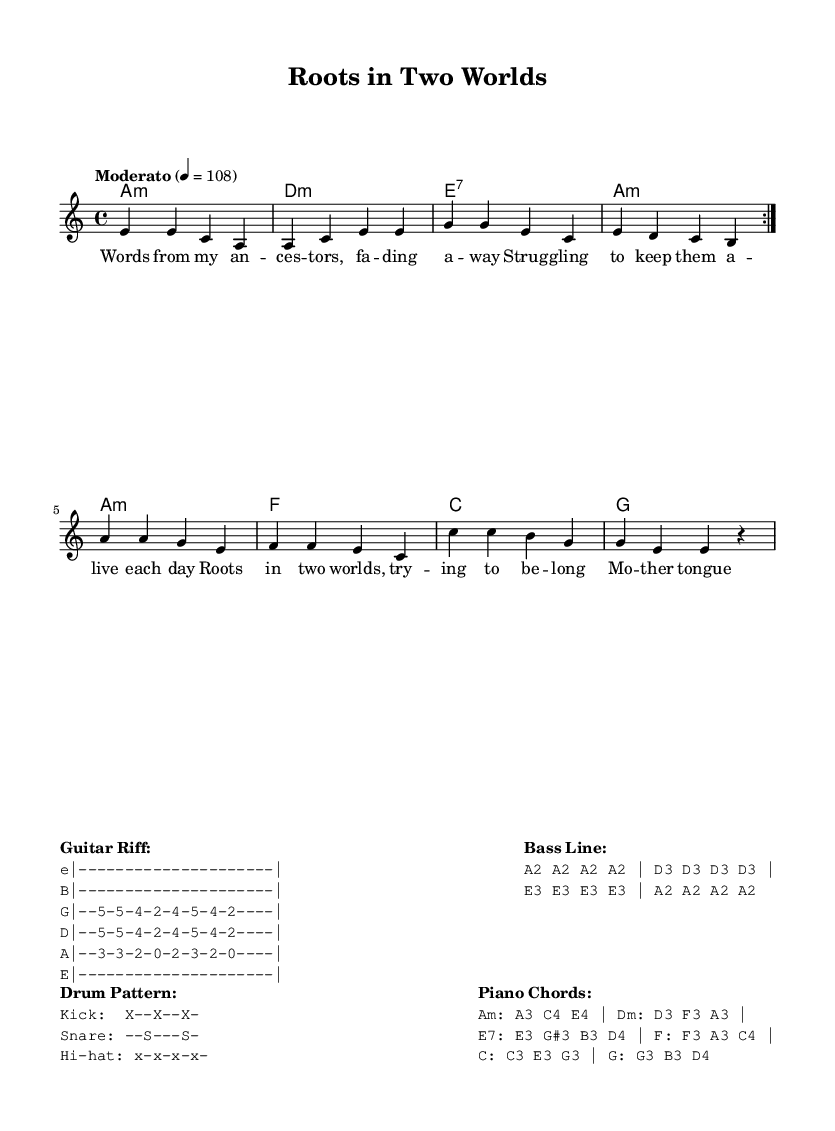What is the key signature of this music? The key signature is A minor, which has no sharps or flats, as indicated at the beginning of the sheet music.
Answer: A minor What is the time signature of this music? The time signature is 4/4, which is noted at the beginning of the score as well. This means there are four beats in each measure.
Answer: 4/4 What tempo marking does this piece have? The tempo marking is "Moderato," which indicates a moderate pace, further specified by the marking of 4 = 108, suggesting the quarter note gets 108 beats per minute.
Answer: Moderato How many measures are in the melody section? The melody section consists of 8 measures, as counted by looking at the notation which includes repeated sections.
Answer: 8 Which chord is played in the first measure? The chord played in the first measure is A minor, as indicated in the chord symbols above the staff.
Answer: A minor What type of music is represented by this piece? This piece represents the Blues genre, specifically contemporary blues, which is characterized by its themes of emotional struggle and identity.
Answer: Blues What is the main theme addressed in the lyrics? The main theme addressed in the lyrics is the struggle to preserve cultural identity and language, as seen in references to ancestors and the mother tongue.
Answer: Cultural identity 